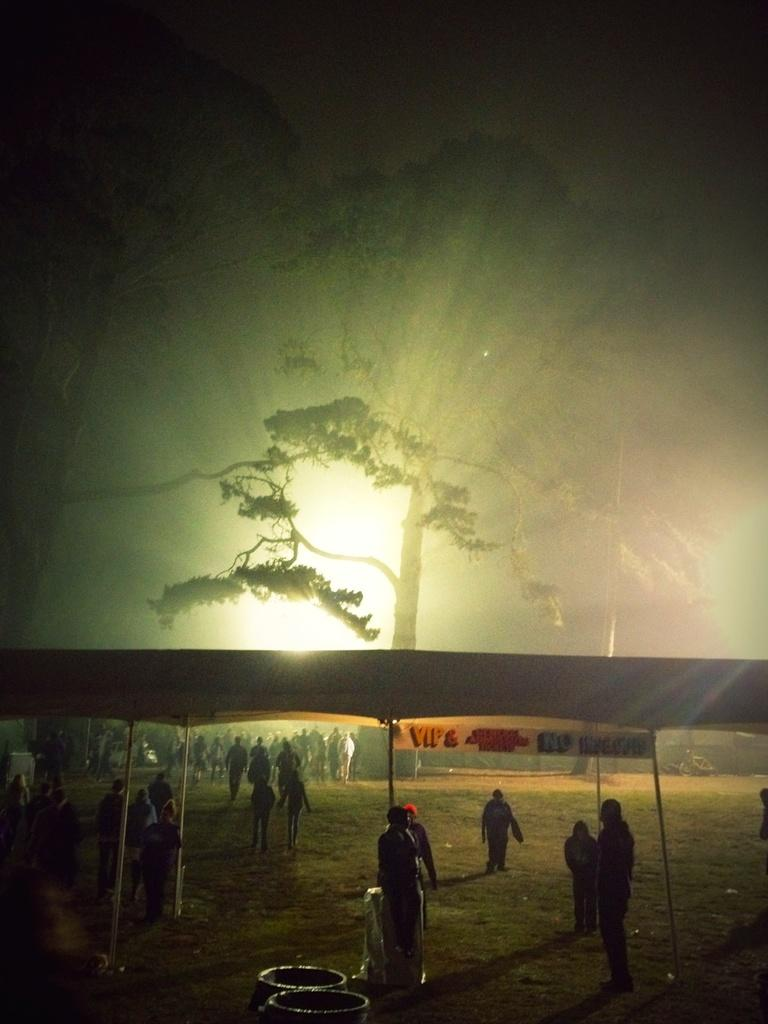What are the people in the image doing? The people in the image are standing on the ground. What can be seen in the background of the image? There are trees and a tent in the background of the image. Are there any other objects on the ground in the background? Yes, there are other objects on the ground in the background of the image. Can you see the cow smiling in the image? There is no cow present in the image, so it is not possible to see a cow smiling. 